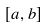Convert formula to latex. <formula><loc_0><loc_0><loc_500><loc_500>[ a , b ]</formula> 